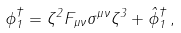<formula> <loc_0><loc_0><loc_500><loc_500>\phi _ { 1 } ^ { \dagger } = \zeta ^ { 2 } F _ { \mu \nu } \sigma ^ { \mu \nu } \zeta ^ { 3 } + \hat { \phi } _ { 1 } ^ { \dagger } \, ,</formula> 